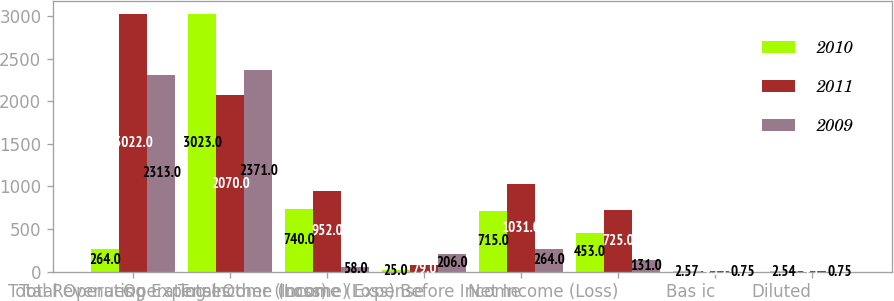<chart> <loc_0><loc_0><loc_500><loc_500><stacked_bar_chart><ecel><fcel>Total Revenues<fcel>Total Operating Expenses<fcel>Operating Income (Loss)<fcel>Total Other (Income) Expense<fcel>Income (Loss) Before Income<fcel>Net Income (Loss)<fcel>Bas ic<fcel>Diluted<nl><fcel>2010<fcel>264<fcel>3023<fcel>740<fcel>25<fcel>715<fcel>453<fcel>2.57<fcel>2.54<nl><fcel>2011<fcel>3022<fcel>2070<fcel>952<fcel>79<fcel>1031<fcel>725<fcel>4.15<fcel>4.1<nl><fcel>2009<fcel>2313<fcel>2371<fcel>58<fcel>206<fcel>264<fcel>131<fcel>0.75<fcel>0.75<nl></chart> 